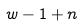Convert formula to latex. <formula><loc_0><loc_0><loc_500><loc_500>w - 1 + n</formula> 